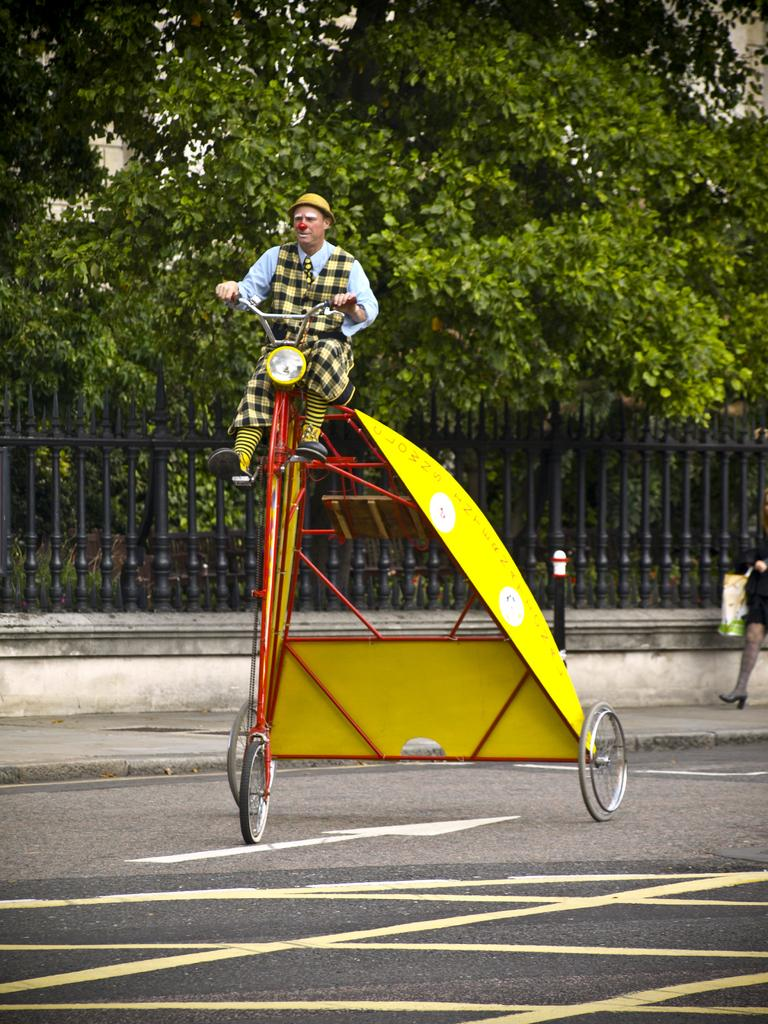How many people are in the image? There are two persons in the image. What is one person doing in the image? One person is riding a bicycle. What can be seen in the image that might be used for support or safety? There are railings and poles in the image. What type of natural elements can be seen in the image? There are trees in the image. What type of man-made structure is visible in the image? There is a building in the image. What type of grain can be seen on the floor in the image? There is no grain visible on the floor in the image. What shape is the building in the image? The shape of the building cannot be determined from the image alone, as only a portion of it is visible. 